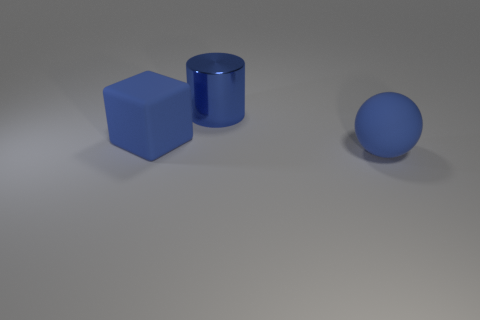Add 1 big rubber cylinders. How many objects exist? 4 Subtract all cubes. How many objects are left? 2 Subtract 0 purple cubes. How many objects are left? 3 Subtract all cylinders. Subtract all big cyan matte spheres. How many objects are left? 2 Add 1 large matte blocks. How many large matte blocks are left? 2 Add 1 tiny metal blocks. How many tiny metal blocks exist? 1 